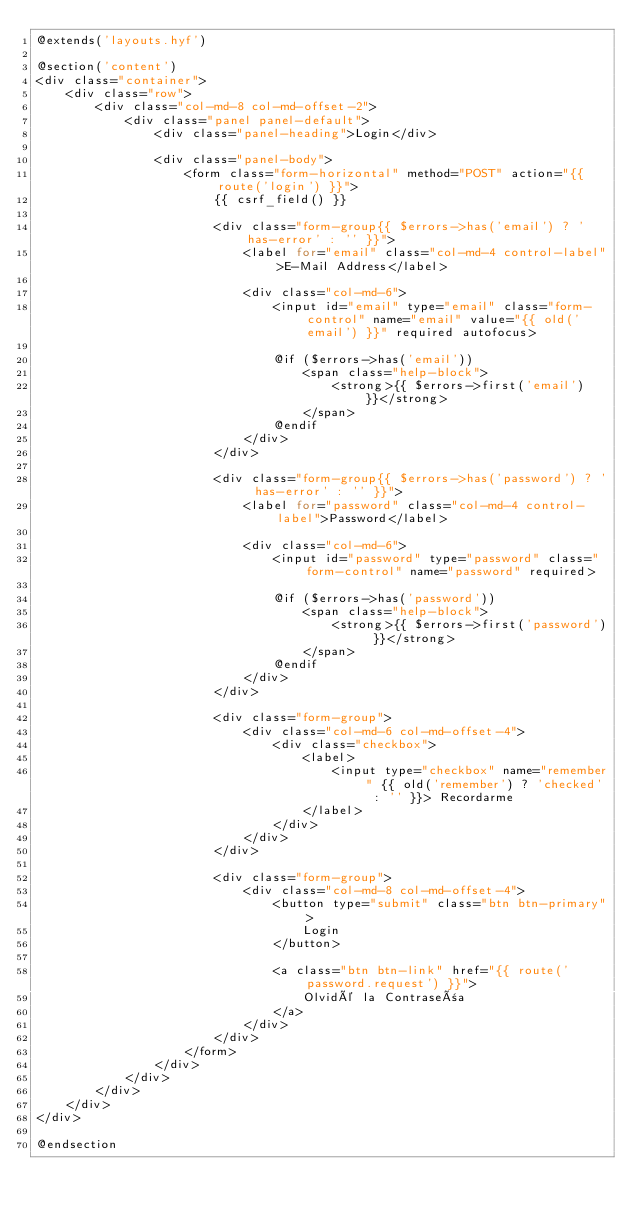<code> <loc_0><loc_0><loc_500><loc_500><_PHP_>@extends('layouts.hyf')

@section('content')
<div class="container">
    <div class="row">
        <div class="col-md-8 col-md-offset-2">
            <div class="panel panel-default">
                <div class="panel-heading">Login</div>

                <div class="panel-body">
                    <form class="form-horizontal" method="POST" action="{{ route('login') }}">
                        {{ csrf_field() }}

                        <div class="form-group{{ $errors->has('email') ? ' has-error' : '' }}">
                            <label for="email" class="col-md-4 control-label">E-Mail Address</label>

                            <div class="col-md-6">
                                <input id="email" type="email" class="form-control" name="email" value="{{ old('email') }}" required autofocus>

                                @if ($errors->has('email'))
                                    <span class="help-block">
                                        <strong>{{ $errors->first('email') }}</strong>
                                    </span>
                                @endif
                            </div>
                        </div>

                        <div class="form-group{{ $errors->has('password') ? ' has-error' : '' }}">
                            <label for="password" class="col-md-4 control-label">Password</label>

                            <div class="col-md-6">
                                <input id="password" type="password" class="form-control" name="password" required>

                                @if ($errors->has('password'))
                                    <span class="help-block">
                                        <strong>{{ $errors->first('password') }}</strong>
                                    </span>
                                @endif
                            </div>
                        </div>

                        <div class="form-group">
                            <div class="col-md-6 col-md-offset-4">
                                <div class="checkbox">
                                    <label>
                                        <input type="checkbox" name="remember" {{ old('remember') ? 'checked' : '' }}> Recordarme
                                    </label>
                                </div>
                            </div>
                        </div>

                        <div class="form-group">
                            <div class="col-md-8 col-md-offset-4">
                                <button type="submit" class="btn btn-primary">
                                    Login
                                </button>

                                <a class="btn btn-link" href="{{ route('password.request') }}">
                                    Olvidé la Contraseña
                                </a>
                            </div>
                        </div>
                    </form>
                </div>
            </div>
        </div>
    </div>
</div>

@endsection


</code> 